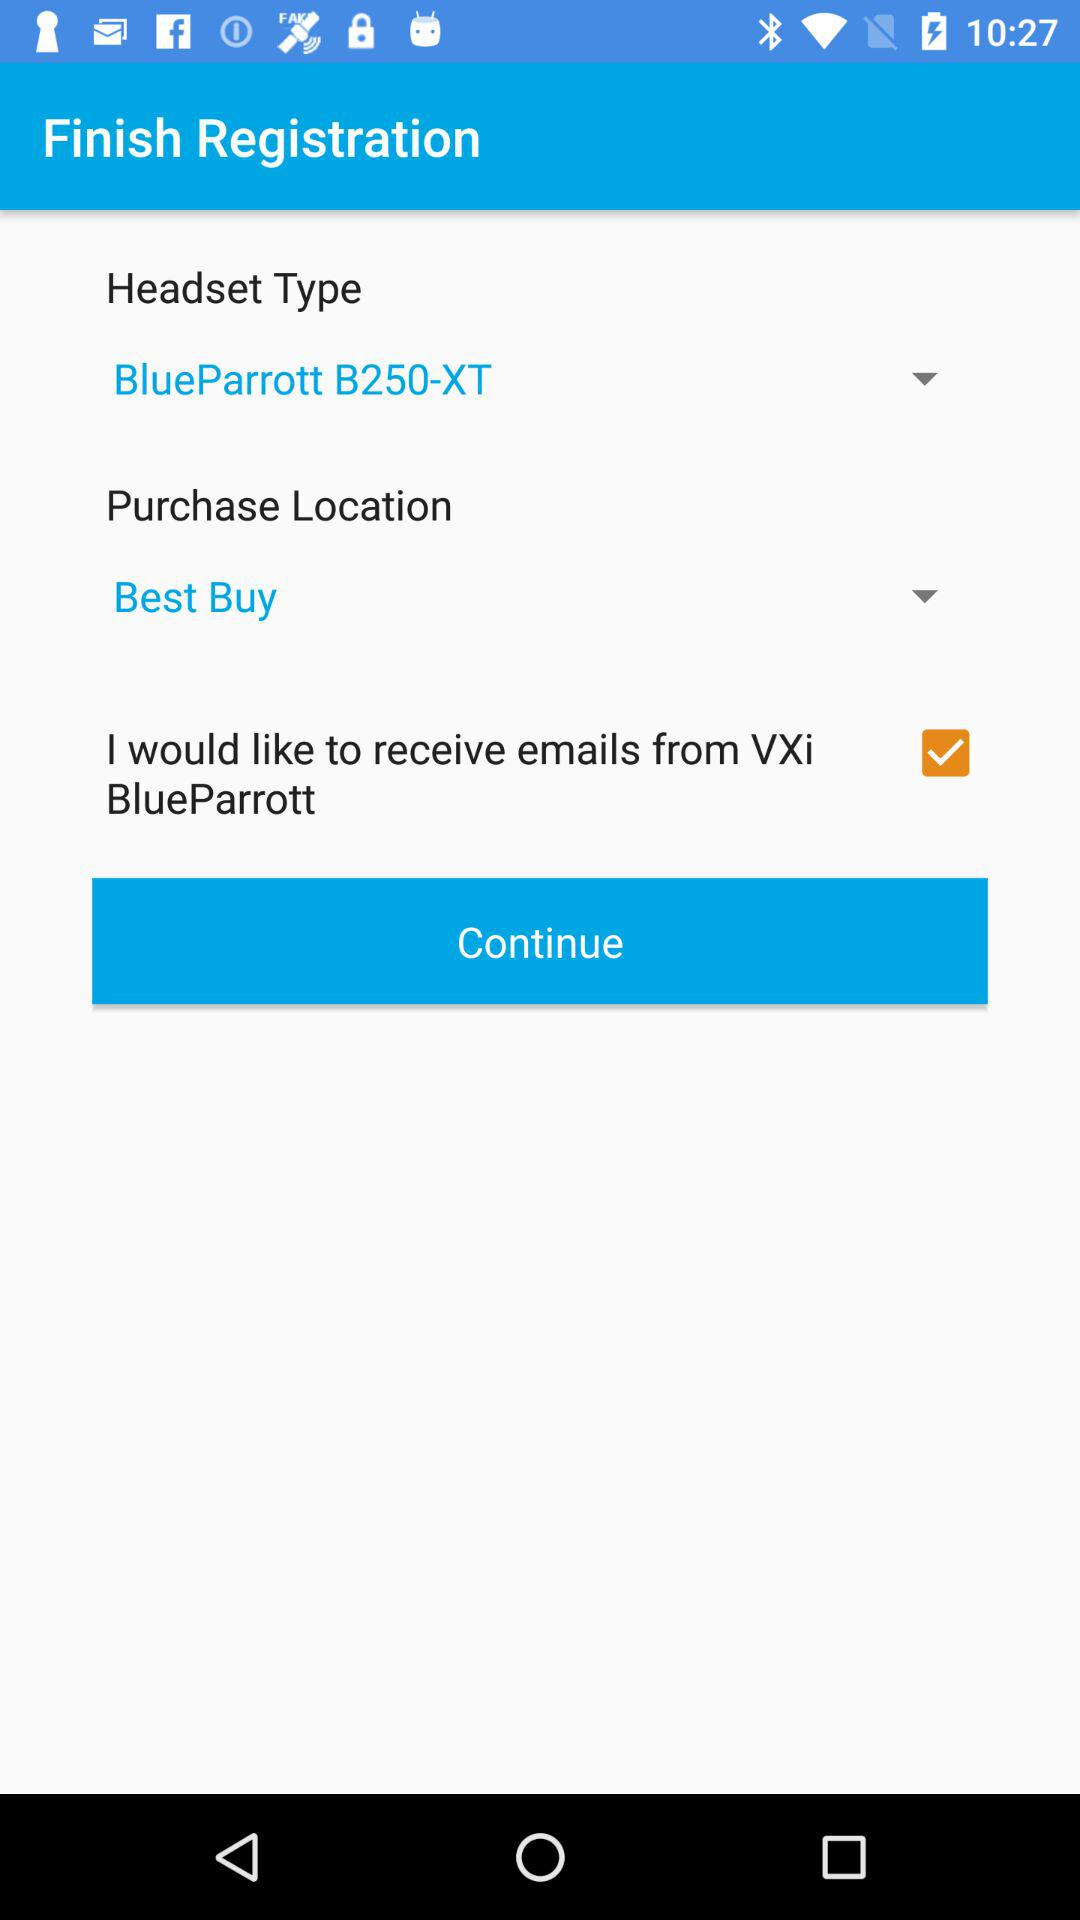What is the headset type? The headset type is "BlueParrott B250-XT". 